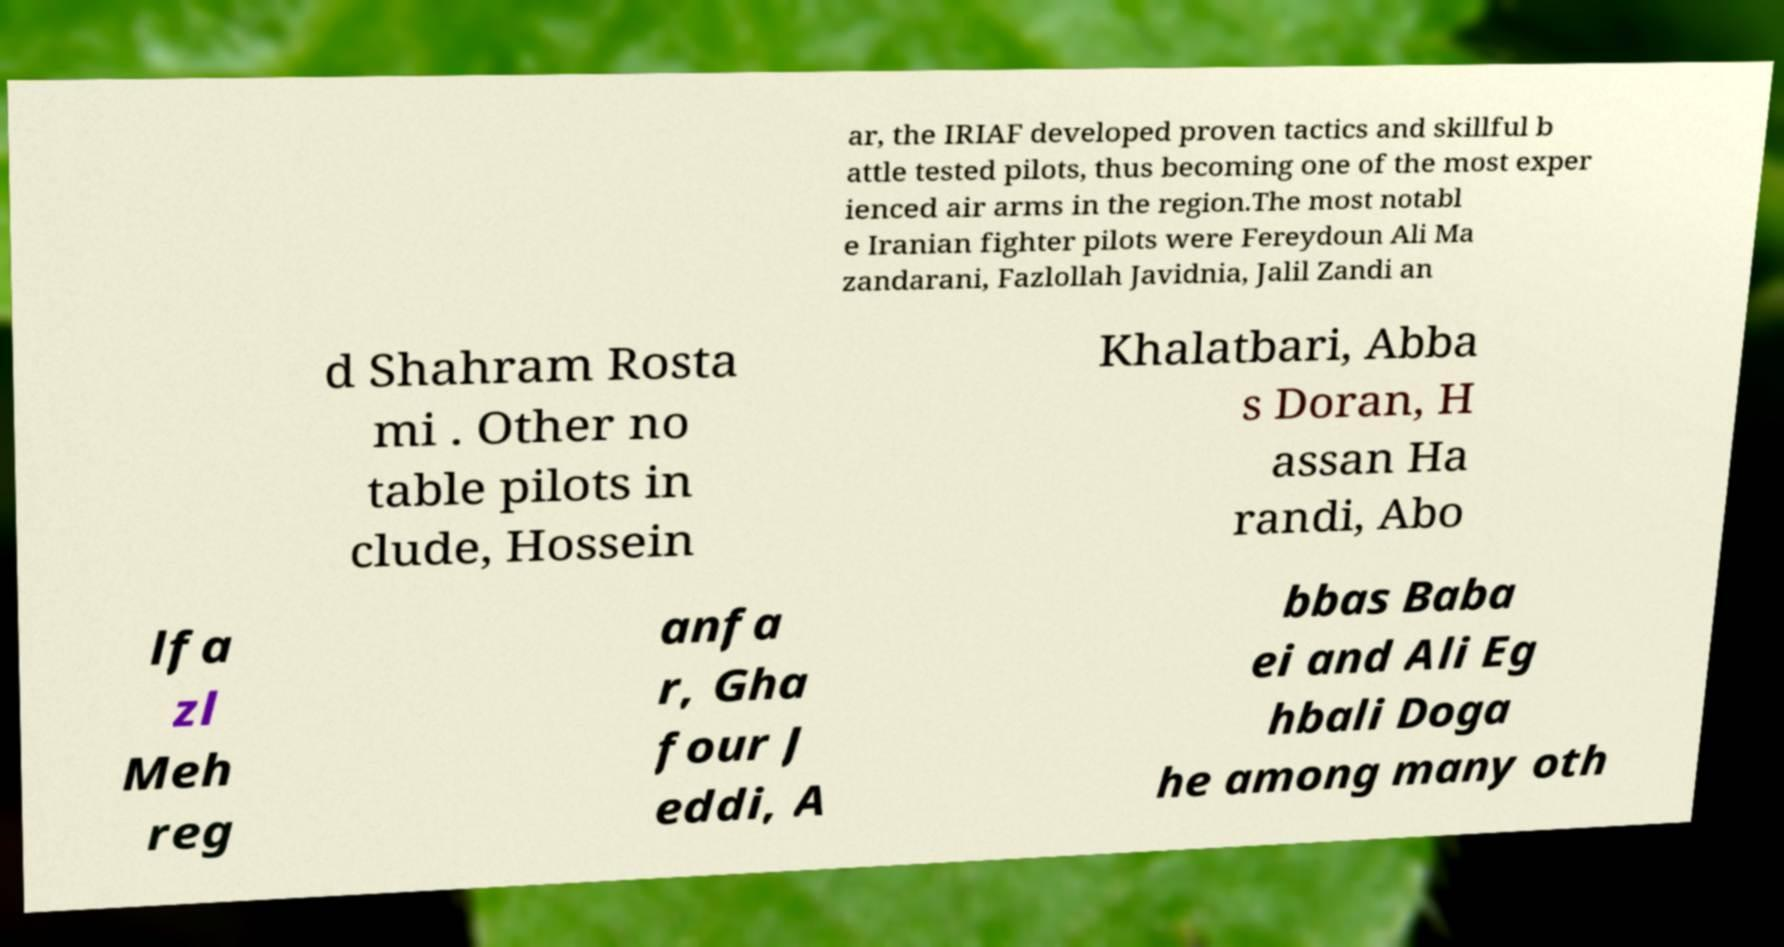I need the written content from this picture converted into text. Can you do that? ar, the IRIAF developed proven tactics and skillful b attle tested pilots, thus becoming one of the most exper ienced air arms in the region.The most notabl e Iranian fighter pilots were Fereydoun Ali Ma zandarani, Fazlollah Javidnia, Jalil Zandi an d Shahram Rosta mi . Other no table pilots in clude, Hossein Khalatbari, Abba s Doran, H assan Ha randi, Abo lfa zl Meh reg anfa r, Gha four J eddi, A bbas Baba ei and Ali Eg hbali Doga he among many oth 